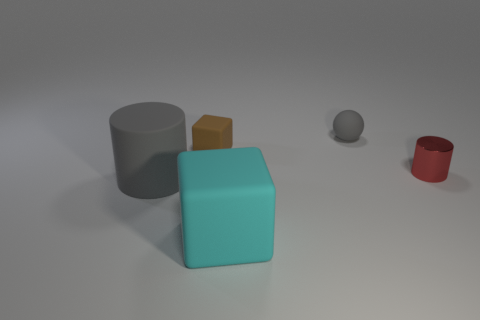Does the rubber sphere have the same color as the matte cylinder?
Provide a short and direct response. Yes. How many other objects are there of the same color as the large matte cylinder?
Your response must be concise. 1. What number of other things are the same material as the big cyan cube?
Provide a short and direct response. 3. What number of blue metal objects are there?
Provide a succinct answer. 0. What number of things are cylinders or gray rubber things in front of the red cylinder?
Your response must be concise. 2. Is there any other thing that has the same shape as the tiny gray matte thing?
Make the answer very short. No. Do the gray matte thing to the right of the brown rubber object and the tiny brown matte object have the same size?
Ensure brevity in your answer.  Yes. What number of shiny things are tiny purple objects or tiny red cylinders?
Provide a succinct answer. 1. What size is the cube in front of the gray matte cylinder?
Ensure brevity in your answer.  Large. Do the large gray object and the small red shiny thing have the same shape?
Your answer should be very brief. Yes. 